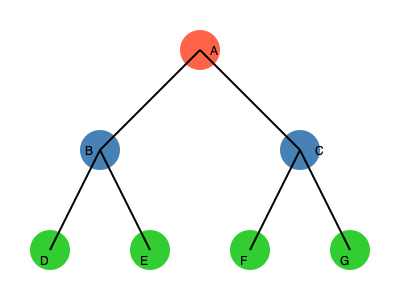In the given node-link diagram representing a social network, what is the betweenness centrality of node A? Assume that betweenness centrality is calculated based on the number of shortest paths passing through a node, and that all edges have equal weight. To calculate the betweenness centrality of node A, we need to follow these steps:

1. Identify all pairs of nodes that are not directly connected to each other.
2. Calculate the shortest paths between these pairs.
3. Determine how many of these shortest paths pass through node A.
4. Sum up the fraction of shortest paths that pass through A for each pair.

Let's go through this process:

1. Pairs of nodes not directly connected:
   (B,C), (B,F), (B,G), (C,D), (C,E), (D,E), (D,F), (D,G), (E,F), (E,G)

2. Shortest paths for these pairs:
   (B,C): B-A-C
   (B,F): B-A-C-F
   (B,G): B-A-C-G
   (C,D): C-A-B-D
   (C,E): C-A-B-E
   (D,E): D-B-E
   (D,F): D-B-A-C-F
   (D,G): D-B-A-C-G
   (E,F): E-B-A-C-F
   (E,G): E-B-A-C-G

3. Shortest paths passing through A:
   (B,C), (B,F), (B,G), (C,D), (C,E), (D,F), (D,G), (E,F), (E,G)

4. Calculating the fraction and sum:
   For each pair, the fraction is 1 as there is only one shortest path, and it passes through A.
   Total sum: 9

Therefore, the betweenness centrality of node A is 9.

Note: This calculation assumes unweighted edges and does not normalize the result. In some definitions, the result might be divided by the total number of pairs of nodes not including A, which would be $\binom{6}{2} = 15$ in this case, giving a normalized betweenness centrality of $9/15 = 0.6$.
Answer: 9 